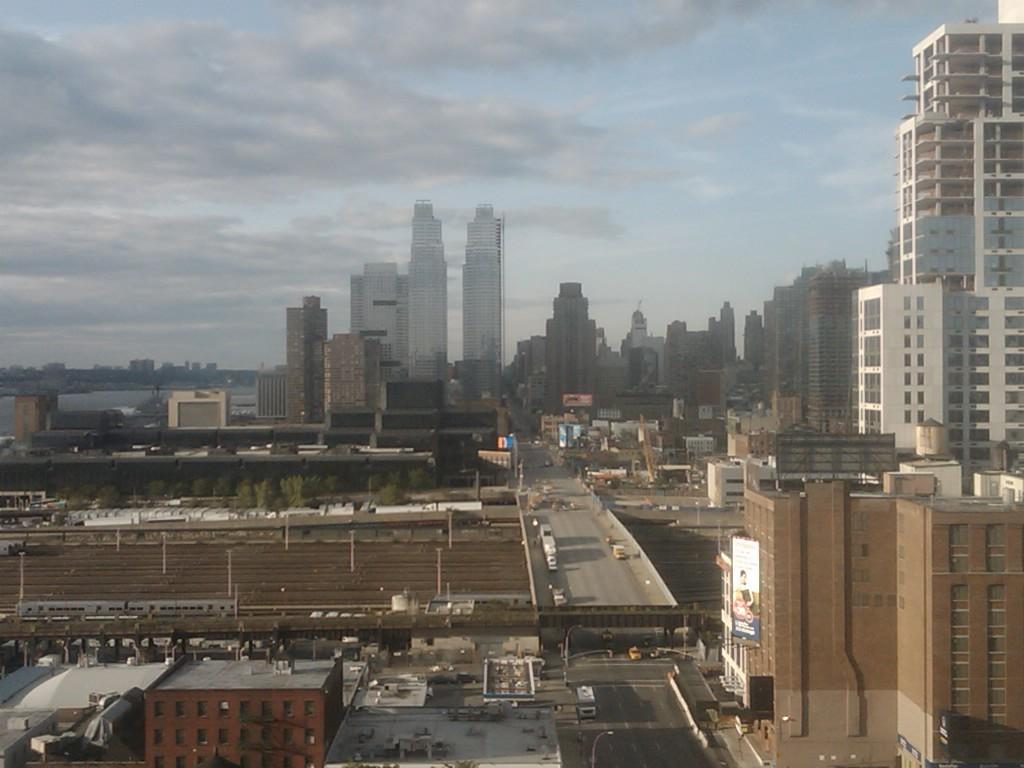What type of structures can be seen in the image? There are buildings in the image. What is happening on the road in the image? There are vehicles on the road in the image. What feature is present that allows people or vehicles to cross over a body of water? There is a bridge in the image. What type of vegetation can be seen in the image? There are trees in the image. What are the tall, thin objects that support wires or other structures? There are poles in the image. What part of the natural environment is visible in the image? The sky is visible in the image. What can be seen in the sky that indicates the weather or time of day? Clouds are present in the sky. What is the noise level in the image? The noise level cannot be determined from the image alone, as it does not contain any information about the sounds present. Is there an ongoing attack in the image? There is no indication of an attack in the image; it simply shows buildings, vehicles, a bridge, trees, poles, and the sky. 